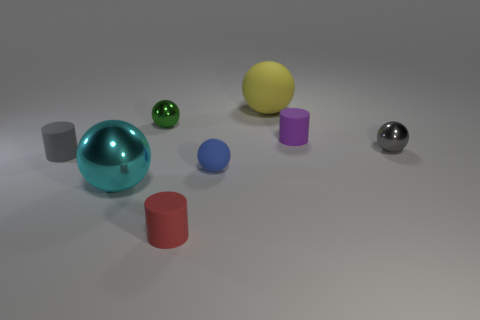The big metal thing that is the same shape as the big yellow rubber object is what color?
Give a very brief answer. Cyan. What material is the small cylinder that is both right of the big cyan thing and behind the large cyan metal thing?
Your response must be concise. Rubber. Is the size of the metallic ball that is to the right of the green metallic object the same as the green sphere?
Give a very brief answer. Yes. What is the cyan ball made of?
Your answer should be compact. Metal. What is the color of the small rubber object that is to the left of the large metallic sphere?
Make the answer very short. Gray. How many large objects are cyan shiny spheres or yellow spheres?
Your answer should be compact. 2. There is a rubber sphere that is in front of the gray shiny ball; is it the same color as the matte cylinder on the left side of the tiny red rubber object?
Keep it short and to the point. No. What number of other objects are there of the same color as the big rubber object?
Keep it short and to the point. 0. What number of blue things are large matte balls or shiny blocks?
Give a very brief answer. 0. There is a large cyan shiny thing; does it have the same shape as the large object behind the green thing?
Your answer should be compact. Yes. 